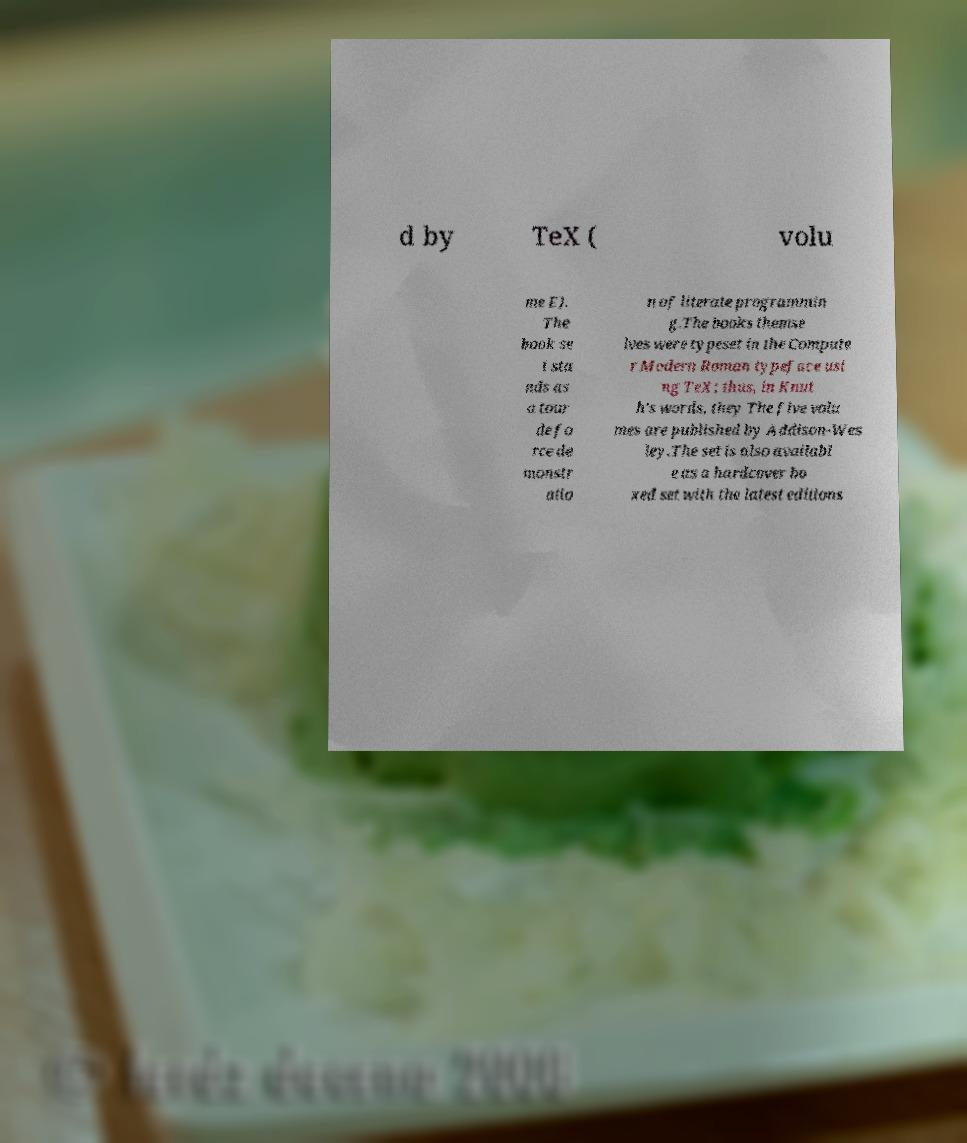Please read and relay the text visible in this image. What does it say? d by TeX ( volu me E). The book se t sta nds as a tour de fo rce de monstr atio n of literate programmin g.The books themse lves were typeset in the Compute r Modern Roman typeface usi ng TeX; thus, in Knut h's words, they The five volu mes are published by Addison-Wes ley.The set is also availabl e as a hardcover bo xed set with the latest editions 